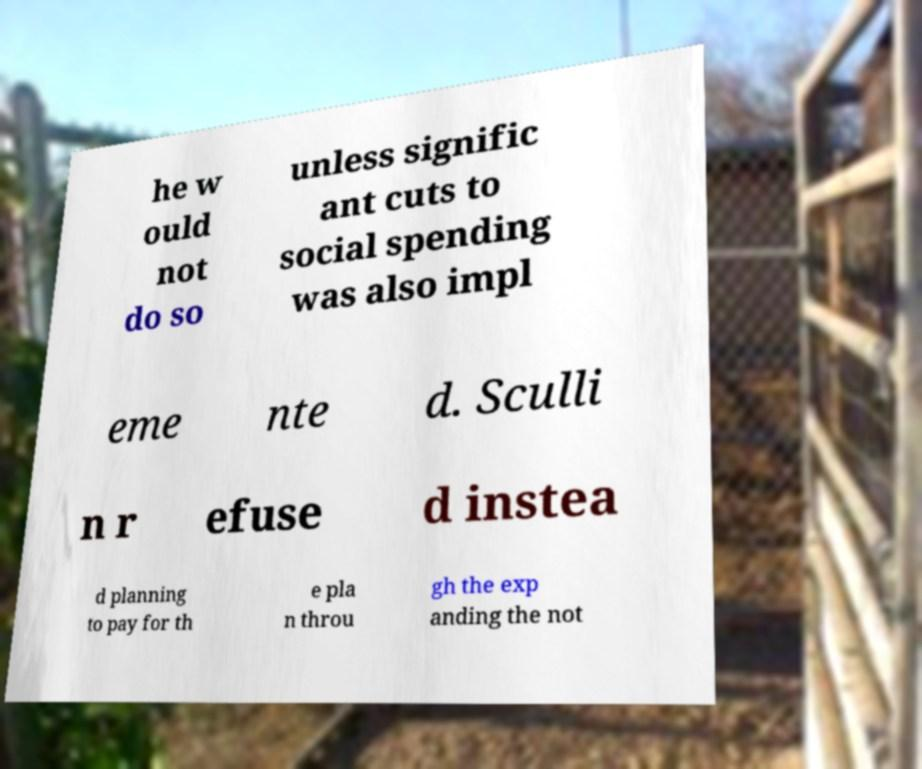Could you assist in decoding the text presented in this image and type it out clearly? he w ould not do so unless signific ant cuts to social spending was also impl eme nte d. Sculli n r efuse d instea d planning to pay for th e pla n throu gh the exp anding the not 